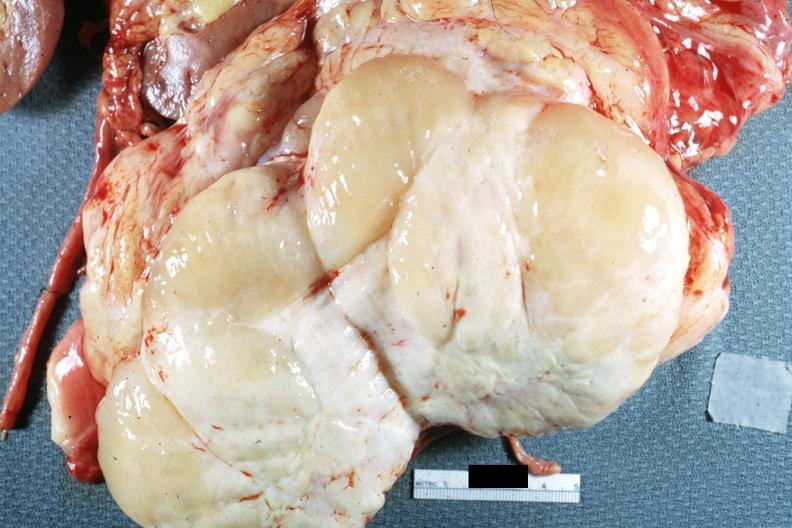s nodular tumor cut surface natural color yellow and white typical gross sarcoma?
Answer the question using a single word or phrase. Yes 